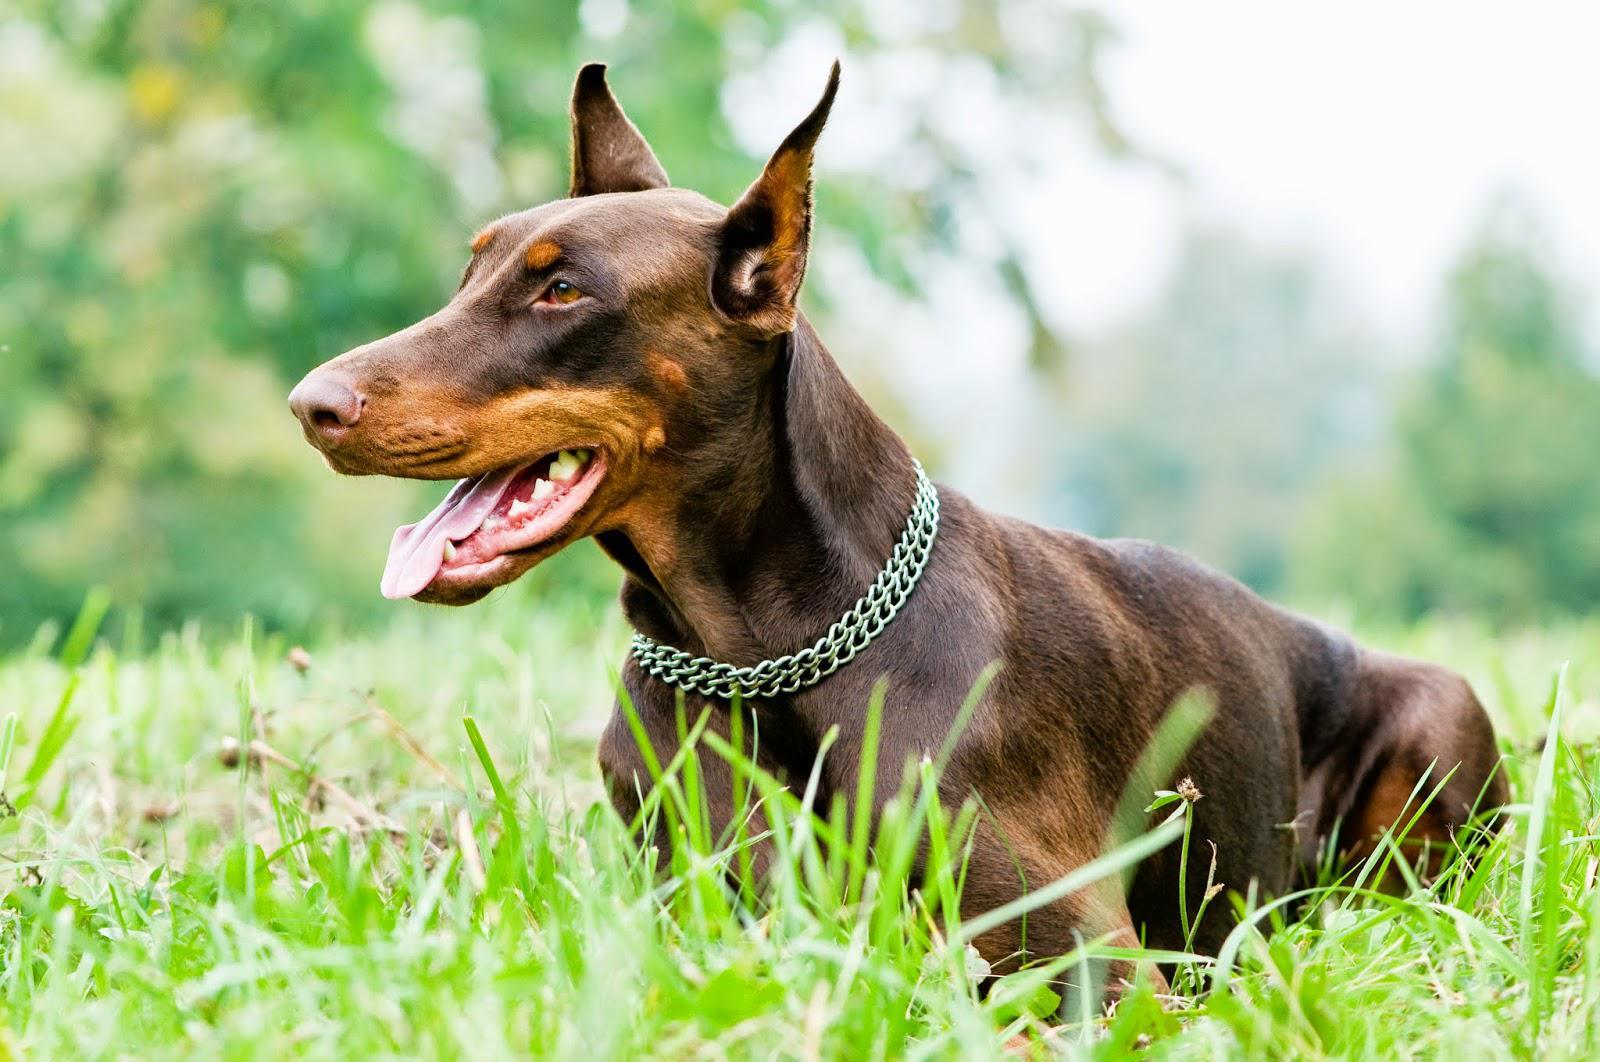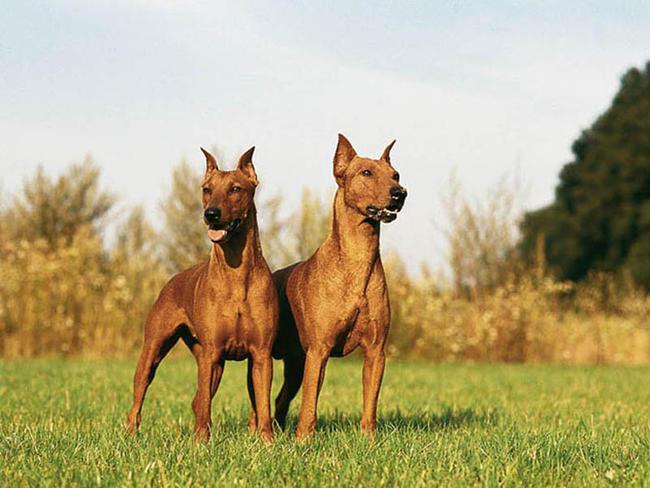The first image is the image on the left, the second image is the image on the right. Examine the images to the left and right. Is the description "One image includes a non-standing doberman wearing a chain collar, and the other image shows at least two dogs standing side-by-side on the grass." accurate? Answer yes or no. Yes. The first image is the image on the left, the second image is the image on the right. Considering the images on both sides, is "The right image contains exactly two dogs." valid? Answer yes or no. Yes. 